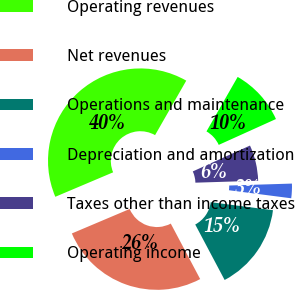<chart> <loc_0><loc_0><loc_500><loc_500><pie_chart><fcel>Operating revenues<fcel>Net revenues<fcel>Operations and maintenance<fcel>Depreciation and amortization<fcel>Taxes other than income taxes<fcel>Operating income<nl><fcel>39.65%<fcel>26.39%<fcel>15.2%<fcel>2.54%<fcel>6.26%<fcel>9.97%<nl></chart> 